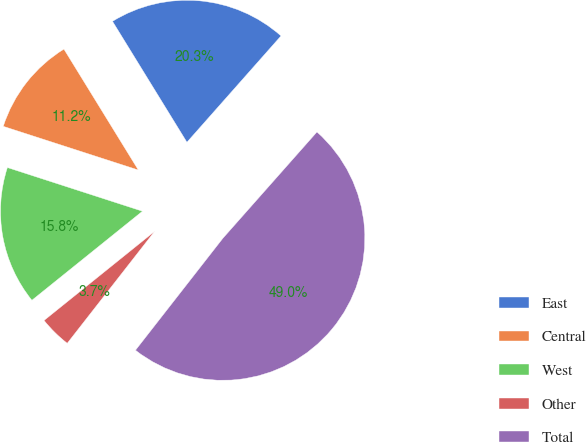Convert chart. <chart><loc_0><loc_0><loc_500><loc_500><pie_chart><fcel>East<fcel>Central<fcel>West<fcel>Other<fcel>Total<nl><fcel>20.31%<fcel>11.24%<fcel>15.77%<fcel>3.66%<fcel>49.02%<nl></chart> 